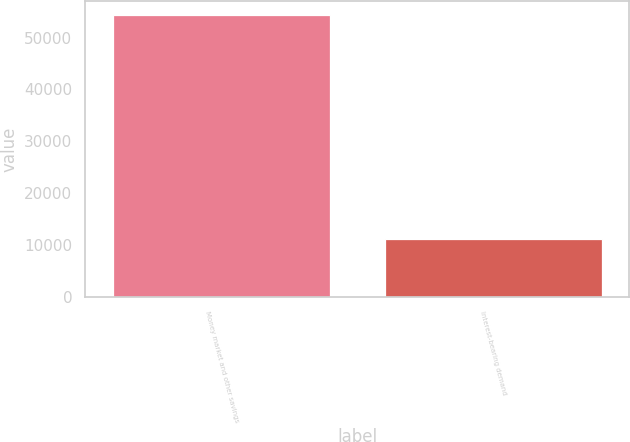<chart> <loc_0><loc_0><loc_500><loc_500><bar_chart><fcel>Money market and other savings<fcel>Interest-bearing demand<nl><fcel>54318<fcel>11227<nl></chart> 